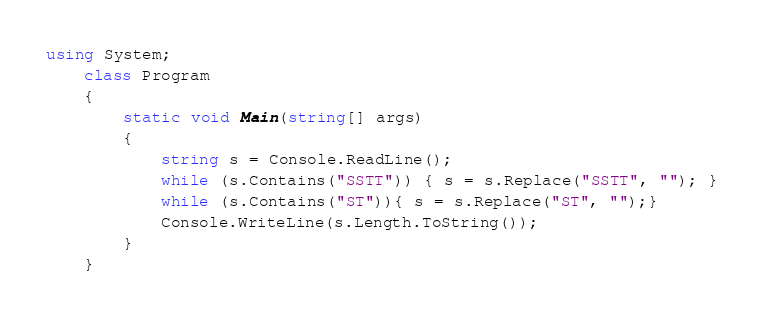Convert code to text. <code><loc_0><loc_0><loc_500><loc_500><_C#_>using System;
    class Program
    {
        static void Main(string[] args)
        {
            string s = Console.ReadLine();
            while (s.Contains("SSTT")) { s = s.Replace("SSTT", ""); }
            while (s.Contains("ST")){ s = s.Replace("ST", "");}
            Console.WriteLine(s.Length.ToString());
        }
    }
</code> 